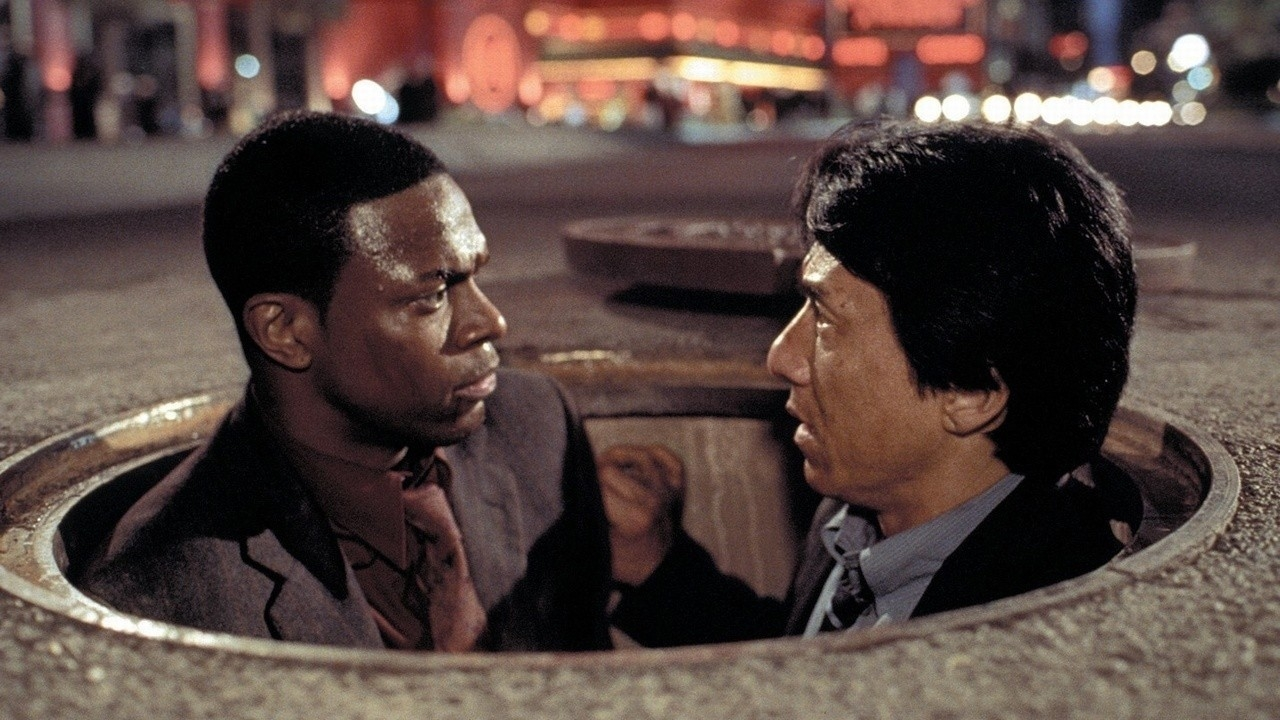Reflect on how the lighting in this image contributes to the narrative. The lighting in this image significantly contributes to the narrative by highlighting the tension and urgency of the scene. The dim, ambient street lights cast soft glows and create stark shadows that accentuate the serious expressions on the characters' faces. The red fountain light in the background adds a sense of danger and urgency, enhancing the dramatic atmosphere. This kind of lighting suggests that the characters are in a precarious situation, heightening the audience’s anticipation of what might occur next. 